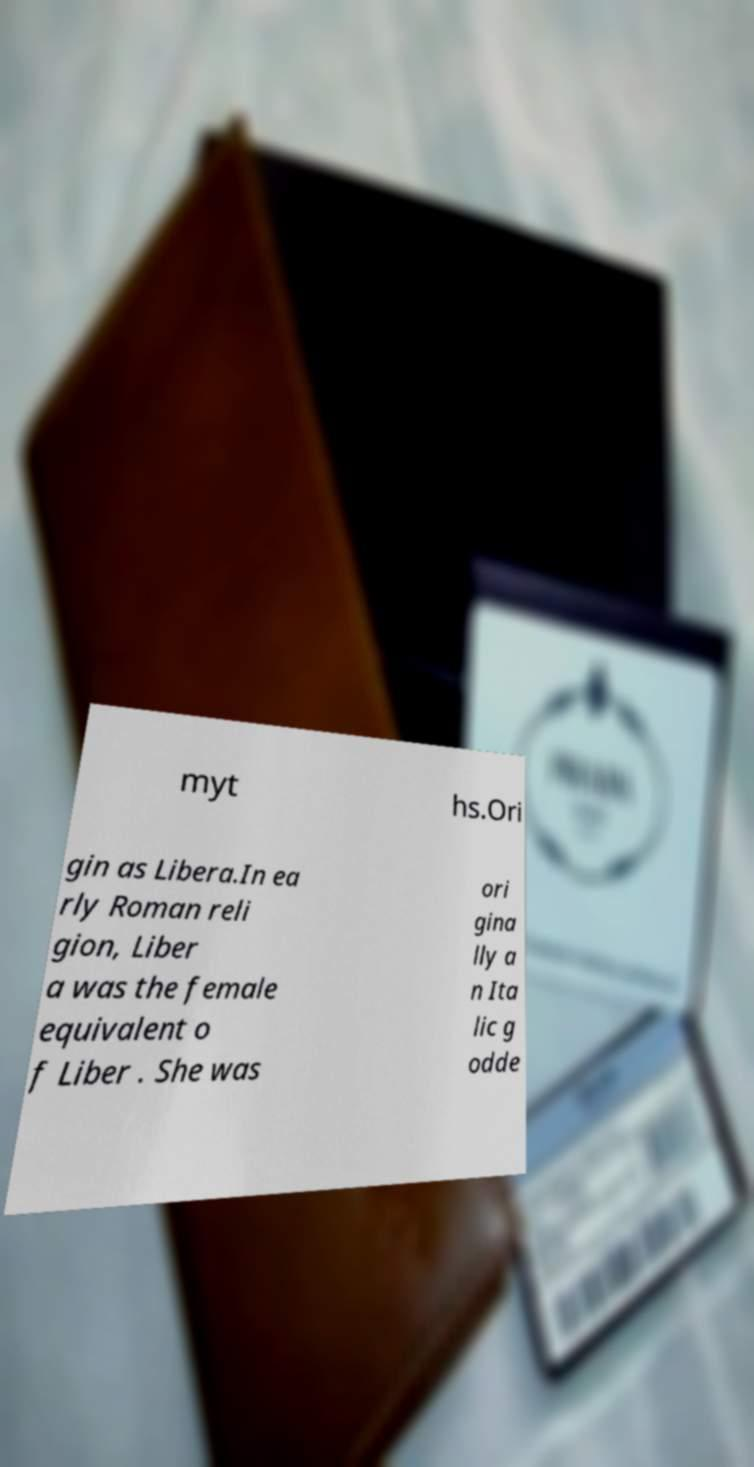There's text embedded in this image that I need extracted. Can you transcribe it verbatim? myt hs.Ori gin as Libera.In ea rly Roman reli gion, Liber a was the female equivalent o f Liber . She was ori gina lly a n Ita lic g odde 